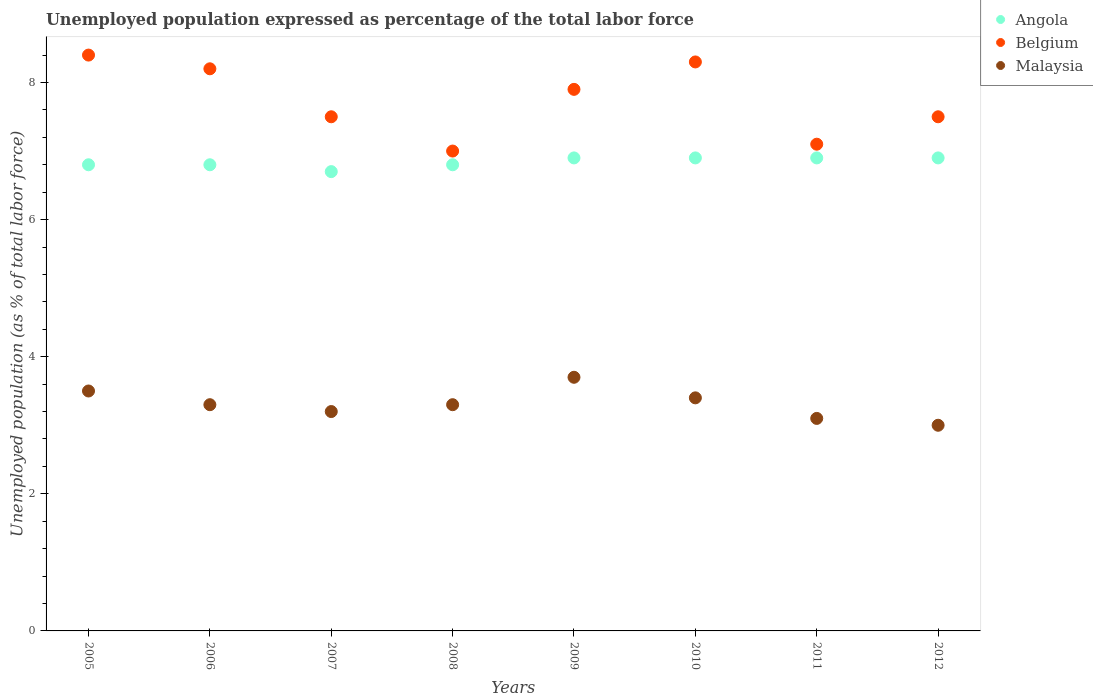How many different coloured dotlines are there?
Your answer should be very brief. 3. Is the number of dotlines equal to the number of legend labels?
Make the answer very short. Yes. What is the unemployment in in Belgium in 2007?
Ensure brevity in your answer.  7.5. Across all years, what is the maximum unemployment in in Belgium?
Your answer should be very brief. 8.4. Across all years, what is the minimum unemployment in in Angola?
Offer a very short reply. 6.7. In which year was the unemployment in in Malaysia minimum?
Your response must be concise. 2012. What is the total unemployment in in Belgium in the graph?
Your response must be concise. 61.9. What is the difference between the unemployment in in Malaysia in 2008 and that in 2010?
Your answer should be compact. -0.1. What is the difference between the unemployment in in Belgium in 2011 and the unemployment in in Malaysia in 2010?
Your answer should be compact. 3.7. What is the average unemployment in in Angola per year?
Your answer should be compact. 6.84. In the year 2009, what is the difference between the unemployment in in Angola and unemployment in in Malaysia?
Give a very brief answer. 3.2. In how many years, is the unemployment in in Angola greater than 8 %?
Make the answer very short. 0. What is the ratio of the unemployment in in Angola in 2007 to that in 2008?
Your response must be concise. 0.99. What is the difference between the highest and the second highest unemployment in in Malaysia?
Offer a very short reply. 0.2. What is the difference between the highest and the lowest unemployment in in Angola?
Provide a short and direct response. 0.2. In how many years, is the unemployment in in Angola greater than the average unemployment in in Angola taken over all years?
Provide a succinct answer. 4. Is it the case that in every year, the sum of the unemployment in in Belgium and unemployment in in Malaysia  is greater than the unemployment in in Angola?
Make the answer very short. Yes. How many dotlines are there?
Offer a terse response. 3. How many years are there in the graph?
Provide a short and direct response. 8. Where does the legend appear in the graph?
Your response must be concise. Top right. How many legend labels are there?
Your response must be concise. 3. How are the legend labels stacked?
Your answer should be compact. Vertical. What is the title of the graph?
Keep it short and to the point. Unemployed population expressed as percentage of the total labor force. What is the label or title of the X-axis?
Offer a very short reply. Years. What is the label or title of the Y-axis?
Keep it short and to the point. Unemployed population (as % of total labor force). What is the Unemployed population (as % of total labor force) of Angola in 2005?
Your answer should be compact. 6.8. What is the Unemployed population (as % of total labor force) of Belgium in 2005?
Keep it short and to the point. 8.4. What is the Unemployed population (as % of total labor force) in Malaysia in 2005?
Make the answer very short. 3.5. What is the Unemployed population (as % of total labor force) in Angola in 2006?
Provide a short and direct response. 6.8. What is the Unemployed population (as % of total labor force) of Belgium in 2006?
Offer a terse response. 8.2. What is the Unemployed population (as % of total labor force) in Malaysia in 2006?
Your response must be concise. 3.3. What is the Unemployed population (as % of total labor force) in Angola in 2007?
Ensure brevity in your answer.  6.7. What is the Unemployed population (as % of total labor force) in Belgium in 2007?
Offer a very short reply. 7.5. What is the Unemployed population (as % of total labor force) in Malaysia in 2007?
Ensure brevity in your answer.  3.2. What is the Unemployed population (as % of total labor force) of Angola in 2008?
Offer a terse response. 6.8. What is the Unemployed population (as % of total labor force) of Belgium in 2008?
Make the answer very short. 7. What is the Unemployed population (as % of total labor force) of Malaysia in 2008?
Offer a very short reply. 3.3. What is the Unemployed population (as % of total labor force) in Angola in 2009?
Your answer should be compact. 6.9. What is the Unemployed population (as % of total labor force) of Belgium in 2009?
Offer a very short reply. 7.9. What is the Unemployed population (as % of total labor force) of Malaysia in 2009?
Give a very brief answer. 3.7. What is the Unemployed population (as % of total labor force) of Angola in 2010?
Make the answer very short. 6.9. What is the Unemployed population (as % of total labor force) of Belgium in 2010?
Your answer should be very brief. 8.3. What is the Unemployed population (as % of total labor force) in Malaysia in 2010?
Provide a succinct answer. 3.4. What is the Unemployed population (as % of total labor force) of Angola in 2011?
Keep it short and to the point. 6.9. What is the Unemployed population (as % of total labor force) of Belgium in 2011?
Ensure brevity in your answer.  7.1. What is the Unemployed population (as % of total labor force) of Malaysia in 2011?
Your answer should be very brief. 3.1. What is the Unemployed population (as % of total labor force) of Angola in 2012?
Offer a terse response. 6.9. What is the Unemployed population (as % of total labor force) of Belgium in 2012?
Your answer should be compact. 7.5. Across all years, what is the maximum Unemployed population (as % of total labor force) of Angola?
Your response must be concise. 6.9. Across all years, what is the maximum Unemployed population (as % of total labor force) of Belgium?
Offer a very short reply. 8.4. Across all years, what is the maximum Unemployed population (as % of total labor force) of Malaysia?
Ensure brevity in your answer.  3.7. Across all years, what is the minimum Unemployed population (as % of total labor force) in Angola?
Provide a succinct answer. 6.7. Across all years, what is the minimum Unemployed population (as % of total labor force) in Malaysia?
Ensure brevity in your answer.  3. What is the total Unemployed population (as % of total labor force) of Angola in the graph?
Your answer should be compact. 54.7. What is the total Unemployed population (as % of total labor force) of Belgium in the graph?
Offer a very short reply. 61.9. What is the total Unemployed population (as % of total labor force) of Malaysia in the graph?
Offer a terse response. 26.5. What is the difference between the Unemployed population (as % of total labor force) in Angola in 2005 and that in 2006?
Make the answer very short. 0. What is the difference between the Unemployed population (as % of total labor force) of Malaysia in 2005 and that in 2007?
Offer a terse response. 0.3. What is the difference between the Unemployed population (as % of total labor force) of Belgium in 2005 and that in 2008?
Keep it short and to the point. 1.4. What is the difference between the Unemployed population (as % of total labor force) in Angola in 2005 and that in 2009?
Offer a terse response. -0.1. What is the difference between the Unemployed population (as % of total labor force) of Malaysia in 2005 and that in 2009?
Offer a very short reply. -0.2. What is the difference between the Unemployed population (as % of total labor force) in Belgium in 2005 and that in 2010?
Your answer should be very brief. 0.1. What is the difference between the Unemployed population (as % of total labor force) of Malaysia in 2005 and that in 2011?
Provide a succinct answer. 0.4. What is the difference between the Unemployed population (as % of total labor force) in Malaysia in 2005 and that in 2012?
Your answer should be very brief. 0.5. What is the difference between the Unemployed population (as % of total labor force) in Angola in 2006 and that in 2007?
Provide a short and direct response. 0.1. What is the difference between the Unemployed population (as % of total labor force) in Belgium in 2006 and that in 2007?
Keep it short and to the point. 0.7. What is the difference between the Unemployed population (as % of total labor force) of Malaysia in 2006 and that in 2007?
Give a very brief answer. 0.1. What is the difference between the Unemployed population (as % of total labor force) of Angola in 2006 and that in 2008?
Your answer should be compact. 0. What is the difference between the Unemployed population (as % of total labor force) of Malaysia in 2006 and that in 2008?
Give a very brief answer. 0. What is the difference between the Unemployed population (as % of total labor force) of Belgium in 2006 and that in 2010?
Offer a terse response. -0.1. What is the difference between the Unemployed population (as % of total labor force) in Belgium in 2006 and that in 2012?
Keep it short and to the point. 0.7. What is the difference between the Unemployed population (as % of total labor force) in Malaysia in 2006 and that in 2012?
Keep it short and to the point. 0.3. What is the difference between the Unemployed population (as % of total labor force) of Angola in 2007 and that in 2008?
Keep it short and to the point. -0.1. What is the difference between the Unemployed population (as % of total labor force) in Belgium in 2007 and that in 2008?
Provide a succinct answer. 0.5. What is the difference between the Unemployed population (as % of total labor force) in Malaysia in 2007 and that in 2008?
Your answer should be compact. -0.1. What is the difference between the Unemployed population (as % of total labor force) of Angola in 2007 and that in 2009?
Keep it short and to the point. -0.2. What is the difference between the Unemployed population (as % of total labor force) of Belgium in 2007 and that in 2009?
Provide a succinct answer. -0.4. What is the difference between the Unemployed population (as % of total labor force) of Malaysia in 2007 and that in 2009?
Your answer should be compact. -0.5. What is the difference between the Unemployed population (as % of total labor force) in Belgium in 2007 and that in 2010?
Ensure brevity in your answer.  -0.8. What is the difference between the Unemployed population (as % of total labor force) of Malaysia in 2007 and that in 2010?
Make the answer very short. -0.2. What is the difference between the Unemployed population (as % of total labor force) in Angola in 2007 and that in 2011?
Provide a short and direct response. -0.2. What is the difference between the Unemployed population (as % of total labor force) in Malaysia in 2007 and that in 2011?
Your answer should be very brief. 0.1. What is the difference between the Unemployed population (as % of total labor force) in Angola in 2008 and that in 2009?
Your answer should be compact. -0.1. What is the difference between the Unemployed population (as % of total labor force) in Belgium in 2008 and that in 2009?
Give a very brief answer. -0.9. What is the difference between the Unemployed population (as % of total labor force) in Malaysia in 2008 and that in 2009?
Your answer should be very brief. -0.4. What is the difference between the Unemployed population (as % of total labor force) of Belgium in 2008 and that in 2010?
Offer a very short reply. -1.3. What is the difference between the Unemployed population (as % of total labor force) of Malaysia in 2008 and that in 2010?
Your answer should be very brief. -0.1. What is the difference between the Unemployed population (as % of total labor force) of Angola in 2008 and that in 2011?
Provide a short and direct response. -0.1. What is the difference between the Unemployed population (as % of total labor force) of Belgium in 2008 and that in 2012?
Keep it short and to the point. -0.5. What is the difference between the Unemployed population (as % of total labor force) of Malaysia in 2008 and that in 2012?
Provide a succinct answer. 0.3. What is the difference between the Unemployed population (as % of total labor force) of Malaysia in 2009 and that in 2010?
Ensure brevity in your answer.  0.3. What is the difference between the Unemployed population (as % of total labor force) of Belgium in 2009 and that in 2011?
Your answer should be compact. 0.8. What is the difference between the Unemployed population (as % of total labor force) in Belgium in 2010 and that in 2011?
Make the answer very short. 1.2. What is the difference between the Unemployed population (as % of total labor force) of Malaysia in 2010 and that in 2011?
Provide a short and direct response. 0.3. What is the difference between the Unemployed population (as % of total labor force) in Belgium in 2010 and that in 2012?
Keep it short and to the point. 0.8. What is the difference between the Unemployed population (as % of total labor force) in Angola in 2011 and that in 2012?
Make the answer very short. 0. What is the difference between the Unemployed population (as % of total labor force) of Belgium in 2011 and that in 2012?
Provide a short and direct response. -0.4. What is the difference between the Unemployed population (as % of total labor force) in Angola in 2005 and the Unemployed population (as % of total labor force) in Belgium in 2006?
Your answer should be very brief. -1.4. What is the difference between the Unemployed population (as % of total labor force) of Angola in 2005 and the Unemployed population (as % of total labor force) of Malaysia in 2006?
Offer a very short reply. 3.5. What is the difference between the Unemployed population (as % of total labor force) in Angola in 2005 and the Unemployed population (as % of total labor force) in Belgium in 2008?
Your response must be concise. -0.2. What is the difference between the Unemployed population (as % of total labor force) of Angola in 2005 and the Unemployed population (as % of total labor force) of Malaysia in 2008?
Provide a succinct answer. 3.5. What is the difference between the Unemployed population (as % of total labor force) in Belgium in 2005 and the Unemployed population (as % of total labor force) in Malaysia in 2008?
Provide a short and direct response. 5.1. What is the difference between the Unemployed population (as % of total labor force) in Angola in 2005 and the Unemployed population (as % of total labor force) in Malaysia in 2009?
Offer a very short reply. 3.1. What is the difference between the Unemployed population (as % of total labor force) of Belgium in 2005 and the Unemployed population (as % of total labor force) of Malaysia in 2009?
Give a very brief answer. 4.7. What is the difference between the Unemployed population (as % of total labor force) of Angola in 2005 and the Unemployed population (as % of total labor force) of Malaysia in 2010?
Keep it short and to the point. 3.4. What is the difference between the Unemployed population (as % of total labor force) of Angola in 2005 and the Unemployed population (as % of total labor force) of Belgium in 2011?
Provide a short and direct response. -0.3. What is the difference between the Unemployed population (as % of total labor force) in Angola in 2005 and the Unemployed population (as % of total labor force) in Malaysia in 2011?
Provide a succinct answer. 3.7. What is the difference between the Unemployed population (as % of total labor force) in Angola in 2005 and the Unemployed population (as % of total labor force) in Belgium in 2012?
Make the answer very short. -0.7. What is the difference between the Unemployed population (as % of total labor force) of Angola in 2005 and the Unemployed population (as % of total labor force) of Malaysia in 2012?
Offer a terse response. 3.8. What is the difference between the Unemployed population (as % of total labor force) in Angola in 2006 and the Unemployed population (as % of total labor force) in Belgium in 2008?
Ensure brevity in your answer.  -0.2. What is the difference between the Unemployed population (as % of total labor force) in Belgium in 2006 and the Unemployed population (as % of total labor force) in Malaysia in 2008?
Give a very brief answer. 4.9. What is the difference between the Unemployed population (as % of total labor force) in Angola in 2006 and the Unemployed population (as % of total labor force) in Belgium in 2009?
Offer a very short reply. -1.1. What is the difference between the Unemployed population (as % of total labor force) of Angola in 2006 and the Unemployed population (as % of total labor force) of Malaysia in 2009?
Provide a succinct answer. 3.1. What is the difference between the Unemployed population (as % of total labor force) of Belgium in 2006 and the Unemployed population (as % of total labor force) of Malaysia in 2009?
Provide a succinct answer. 4.5. What is the difference between the Unemployed population (as % of total labor force) in Angola in 2006 and the Unemployed population (as % of total labor force) in Belgium in 2010?
Provide a short and direct response. -1.5. What is the difference between the Unemployed population (as % of total labor force) in Angola in 2006 and the Unemployed population (as % of total labor force) in Malaysia in 2010?
Offer a terse response. 3.4. What is the difference between the Unemployed population (as % of total labor force) of Belgium in 2006 and the Unemployed population (as % of total labor force) of Malaysia in 2011?
Your response must be concise. 5.1. What is the difference between the Unemployed population (as % of total labor force) of Belgium in 2006 and the Unemployed population (as % of total labor force) of Malaysia in 2012?
Your answer should be compact. 5.2. What is the difference between the Unemployed population (as % of total labor force) of Angola in 2007 and the Unemployed population (as % of total labor force) of Belgium in 2009?
Offer a very short reply. -1.2. What is the difference between the Unemployed population (as % of total labor force) of Angola in 2007 and the Unemployed population (as % of total labor force) of Malaysia in 2009?
Provide a short and direct response. 3. What is the difference between the Unemployed population (as % of total labor force) of Belgium in 2007 and the Unemployed population (as % of total labor force) of Malaysia in 2009?
Make the answer very short. 3.8. What is the difference between the Unemployed population (as % of total labor force) of Angola in 2007 and the Unemployed population (as % of total labor force) of Malaysia in 2010?
Your answer should be compact. 3.3. What is the difference between the Unemployed population (as % of total labor force) of Angola in 2007 and the Unemployed population (as % of total labor force) of Belgium in 2011?
Provide a short and direct response. -0.4. What is the difference between the Unemployed population (as % of total labor force) of Angola in 2007 and the Unemployed population (as % of total labor force) of Malaysia in 2011?
Provide a short and direct response. 3.6. What is the difference between the Unemployed population (as % of total labor force) of Angola in 2008 and the Unemployed population (as % of total labor force) of Malaysia in 2010?
Offer a very short reply. 3.4. What is the difference between the Unemployed population (as % of total labor force) in Belgium in 2008 and the Unemployed population (as % of total labor force) in Malaysia in 2010?
Keep it short and to the point. 3.6. What is the difference between the Unemployed population (as % of total labor force) of Angola in 2008 and the Unemployed population (as % of total labor force) of Belgium in 2012?
Your answer should be compact. -0.7. What is the difference between the Unemployed population (as % of total labor force) of Angola in 2008 and the Unemployed population (as % of total labor force) of Malaysia in 2012?
Ensure brevity in your answer.  3.8. What is the difference between the Unemployed population (as % of total labor force) of Angola in 2009 and the Unemployed population (as % of total labor force) of Belgium in 2010?
Your answer should be very brief. -1.4. What is the difference between the Unemployed population (as % of total labor force) of Angola in 2009 and the Unemployed population (as % of total labor force) of Malaysia in 2010?
Provide a short and direct response. 3.5. What is the difference between the Unemployed population (as % of total labor force) in Angola in 2009 and the Unemployed population (as % of total labor force) in Belgium in 2011?
Keep it short and to the point. -0.2. What is the difference between the Unemployed population (as % of total labor force) in Angola in 2009 and the Unemployed population (as % of total labor force) in Malaysia in 2011?
Offer a terse response. 3.8. What is the difference between the Unemployed population (as % of total labor force) in Belgium in 2009 and the Unemployed population (as % of total labor force) in Malaysia in 2011?
Give a very brief answer. 4.8. What is the difference between the Unemployed population (as % of total labor force) of Angola in 2009 and the Unemployed population (as % of total labor force) of Malaysia in 2012?
Your response must be concise. 3.9. What is the difference between the Unemployed population (as % of total labor force) of Belgium in 2010 and the Unemployed population (as % of total labor force) of Malaysia in 2011?
Provide a short and direct response. 5.2. What is the difference between the Unemployed population (as % of total labor force) of Angola in 2010 and the Unemployed population (as % of total labor force) of Belgium in 2012?
Offer a very short reply. -0.6. What is the difference between the Unemployed population (as % of total labor force) of Belgium in 2010 and the Unemployed population (as % of total labor force) of Malaysia in 2012?
Keep it short and to the point. 5.3. What is the difference between the Unemployed population (as % of total labor force) of Angola in 2011 and the Unemployed population (as % of total labor force) of Belgium in 2012?
Your answer should be compact. -0.6. What is the difference between the Unemployed population (as % of total labor force) of Angola in 2011 and the Unemployed population (as % of total labor force) of Malaysia in 2012?
Offer a terse response. 3.9. What is the difference between the Unemployed population (as % of total labor force) in Belgium in 2011 and the Unemployed population (as % of total labor force) in Malaysia in 2012?
Keep it short and to the point. 4.1. What is the average Unemployed population (as % of total labor force) in Angola per year?
Give a very brief answer. 6.84. What is the average Unemployed population (as % of total labor force) of Belgium per year?
Offer a terse response. 7.74. What is the average Unemployed population (as % of total labor force) of Malaysia per year?
Offer a terse response. 3.31. In the year 2005, what is the difference between the Unemployed population (as % of total labor force) of Angola and Unemployed population (as % of total labor force) of Belgium?
Your answer should be compact. -1.6. In the year 2005, what is the difference between the Unemployed population (as % of total labor force) of Angola and Unemployed population (as % of total labor force) of Malaysia?
Your answer should be very brief. 3.3. In the year 2005, what is the difference between the Unemployed population (as % of total labor force) of Belgium and Unemployed population (as % of total labor force) of Malaysia?
Your answer should be very brief. 4.9. In the year 2006, what is the difference between the Unemployed population (as % of total labor force) of Angola and Unemployed population (as % of total labor force) of Belgium?
Give a very brief answer. -1.4. In the year 2006, what is the difference between the Unemployed population (as % of total labor force) of Angola and Unemployed population (as % of total labor force) of Malaysia?
Make the answer very short. 3.5. In the year 2008, what is the difference between the Unemployed population (as % of total labor force) in Angola and Unemployed population (as % of total labor force) in Malaysia?
Your answer should be compact. 3.5. In the year 2009, what is the difference between the Unemployed population (as % of total labor force) in Angola and Unemployed population (as % of total labor force) in Belgium?
Your response must be concise. -1. In the year 2009, what is the difference between the Unemployed population (as % of total labor force) in Belgium and Unemployed population (as % of total labor force) in Malaysia?
Offer a terse response. 4.2. In the year 2010, what is the difference between the Unemployed population (as % of total labor force) in Angola and Unemployed population (as % of total labor force) in Belgium?
Provide a short and direct response. -1.4. In the year 2011, what is the difference between the Unemployed population (as % of total labor force) in Angola and Unemployed population (as % of total labor force) in Malaysia?
Ensure brevity in your answer.  3.8. What is the ratio of the Unemployed population (as % of total labor force) in Belgium in 2005 to that in 2006?
Your answer should be very brief. 1.02. What is the ratio of the Unemployed population (as % of total labor force) of Malaysia in 2005 to that in 2006?
Keep it short and to the point. 1.06. What is the ratio of the Unemployed population (as % of total labor force) in Angola in 2005 to that in 2007?
Provide a short and direct response. 1.01. What is the ratio of the Unemployed population (as % of total labor force) of Belgium in 2005 to that in 2007?
Provide a short and direct response. 1.12. What is the ratio of the Unemployed population (as % of total labor force) in Malaysia in 2005 to that in 2007?
Keep it short and to the point. 1.09. What is the ratio of the Unemployed population (as % of total labor force) in Malaysia in 2005 to that in 2008?
Provide a short and direct response. 1.06. What is the ratio of the Unemployed population (as % of total labor force) of Angola in 2005 to that in 2009?
Provide a succinct answer. 0.99. What is the ratio of the Unemployed population (as % of total labor force) in Belgium in 2005 to that in 2009?
Keep it short and to the point. 1.06. What is the ratio of the Unemployed population (as % of total labor force) of Malaysia in 2005 to that in 2009?
Offer a very short reply. 0.95. What is the ratio of the Unemployed population (as % of total labor force) in Angola in 2005 to that in 2010?
Ensure brevity in your answer.  0.99. What is the ratio of the Unemployed population (as % of total labor force) in Belgium in 2005 to that in 2010?
Make the answer very short. 1.01. What is the ratio of the Unemployed population (as % of total labor force) in Malaysia in 2005 to that in 2010?
Offer a very short reply. 1.03. What is the ratio of the Unemployed population (as % of total labor force) in Angola in 2005 to that in 2011?
Provide a succinct answer. 0.99. What is the ratio of the Unemployed population (as % of total labor force) of Belgium in 2005 to that in 2011?
Your answer should be very brief. 1.18. What is the ratio of the Unemployed population (as % of total labor force) of Malaysia in 2005 to that in 2011?
Your answer should be very brief. 1.13. What is the ratio of the Unemployed population (as % of total labor force) in Angola in 2005 to that in 2012?
Offer a very short reply. 0.99. What is the ratio of the Unemployed population (as % of total labor force) in Belgium in 2005 to that in 2012?
Offer a very short reply. 1.12. What is the ratio of the Unemployed population (as % of total labor force) in Malaysia in 2005 to that in 2012?
Your answer should be compact. 1.17. What is the ratio of the Unemployed population (as % of total labor force) in Angola in 2006 to that in 2007?
Give a very brief answer. 1.01. What is the ratio of the Unemployed population (as % of total labor force) of Belgium in 2006 to that in 2007?
Offer a terse response. 1.09. What is the ratio of the Unemployed population (as % of total labor force) of Malaysia in 2006 to that in 2007?
Make the answer very short. 1.03. What is the ratio of the Unemployed population (as % of total labor force) in Belgium in 2006 to that in 2008?
Your answer should be very brief. 1.17. What is the ratio of the Unemployed population (as % of total labor force) in Malaysia in 2006 to that in 2008?
Provide a short and direct response. 1. What is the ratio of the Unemployed population (as % of total labor force) of Angola in 2006 to that in 2009?
Your response must be concise. 0.99. What is the ratio of the Unemployed population (as % of total labor force) in Belgium in 2006 to that in 2009?
Offer a very short reply. 1.04. What is the ratio of the Unemployed population (as % of total labor force) in Malaysia in 2006 to that in 2009?
Provide a succinct answer. 0.89. What is the ratio of the Unemployed population (as % of total labor force) in Angola in 2006 to that in 2010?
Your answer should be compact. 0.99. What is the ratio of the Unemployed population (as % of total labor force) in Malaysia in 2006 to that in 2010?
Offer a very short reply. 0.97. What is the ratio of the Unemployed population (as % of total labor force) of Angola in 2006 to that in 2011?
Your response must be concise. 0.99. What is the ratio of the Unemployed population (as % of total labor force) in Belgium in 2006 to that in 2011?
Your response must be concise. 1.15. What is the ratio of the Unemployed population (as % of total labor force) of Malaysia in 2006 to that in 2011?
Make the answer very short. 1.06. What is the ratio of the Unemployed population (as % of total labor force) of Angola in 2006 to that in 2012?
Ensure brevity in your answer.  0.99. What is the ratio of the Unemployed population (as % of total labor force) in Belgium in 2006 to that in 2012?
Offer a terse response. 1.09. What is the ratio of the Unemployed population (as % of total labor force) in Belgium in 2007 to that in 2008?
Your answer should be compact. 1.07. What is the ratio of the Unemployed population (as % of total labor force) of Malaysia in 2007 to that in 2008?
Give a very brief answer. 0.97. What is the ratio of the Unemployed population (as % of total labor force) in Angola in 2007 to that in 2009?
Provide a short and direct response. 0.97. What is the ratio of the Unemployed population (as % of total labor force) in Belgium in 2007 to that in 2009?
Your answer should be very brief. 0.95. What is the ratio of the Unemployed population (as % of total labor force) of Malaysia in 2007 to that in 2009?
Provide a short and direct response. 0.86. What is the ratio of the Unemployed population (as % of total labor force) of Angola in 2007 to that in 2010?
Give a very brief answer. 0.97. What is the ratio of the Unemployed population (as % of total labor force) in Belgium in 2007 to that in 2010?
Your answer should be compact. 0.9. What is the ratio of the Unemployed population (as % of total labor force) of Angola in 2007 to that in 2011?
Ensure brevity in your answer.  0.97. What is the ratio of the Unemployed population (as % of total labor force) of Belgium in 2007 to that in 2011?
Provide a short and direct response. 1.06. What is the ratio of the Unemployed population (as % of total labor force) in Malaysia in 2007 to that in 2011?
Offer a very short reply. 1.03. What is the ratio of the Unemployed population (as % of total labor force) in Angola in 2007 to that in 2012?
Offer a terse response. 0.97. What is the ratio of the Unemployed population (as % of total labor force) of Belgium in 2007 to that in 2012?
Provide a succinct answer. 1. What is the ratio of the Unemployed population (as % of total labor force) in Malaysia in 2007 to that in 2012?
Your answer should be compact. 1.07. What is the ratio of the Unemployed population (as % of total labor force) in Angola in 2008 to that in 2009?
Provide a succinct answer. 0.99. What is the ratio of the Unemployed population (as % of total labor force) of Belgium in 2008 to that in 2009?
Your response must be concise. 0.89. What is the ratio of the Unemployed population (as % of total labor force) of Malaysia in 2008 to that in 2009?
Offer a very short reply. 0.89. What is the ratio of the Unemployed population (as % of total labor force) of Angola in 2008 to that in 2010?
Give a very brief answer. 0.99. What is the ratio of the Unemployed population (as % of total labor force) in Belgium in 2008 to that in 2010?
Offer a very short reply. 0.84. What is the ratio of the Unemployed population (as % of total labor force) of Malaysia in 2008 to that in 2010?
Provide a succinct answer. 0.97. What is the ratio of the Unemployed population (as % of total labor force) in Angola in 2008 to that in 2011?
Ensure brevity in your answer.  0.99. What is the ratio of the Unemployed population (as % of total labor force) of Belgium in 2008 to that in 2011?
Give a very brief answer. 0.99. What is the ratio of the Unemployed population (as % of total labor force) in Malaysia in 2008 to that in 2011?
Offer a terse response. 1.06. What is the ratio of the Unemployed population (as % of total labor force) in Angola in 2008 to that in 2012?
Offer a terse response. 0.99. What is the ratio of the Unemployed population (as % of total labor force) of Malaysia in 2008 to that in 2012?
Make the answer very short. 1.1. What is the ratio of the Unemployed population (as % of total labor force) in Angola in 2009 to that in 2010?
Your answer should be compact. 1. What is the ratio of the Unemployed population (as % of total labor force) in Belgium in 2009 to that in 2010?
Your response must be concise. 0.95. What is the ratio of the Unemployed population (as % of total labor force) in Malaysia in 2009 to that in 2010?
Your response must be concise. 1.09. What is the ratio of the Unemployed population (as % of total labor force) in Belgium in 2009 to that in 2011?
Your answer should be very brief. 1.11. What is the ratio of the Unemployed population (as % of total labor force) of Malaysia in 2009 to that in 2011?
Your answer should be compact. 1.19. What is the ratio of the Unemployed population (as % of total labor force) of Belgium in 2009 to that in 2012?
Provide a short and direct response. 1.05. What is the ratio of the Unemployed population (as % of total labor force) in Malaysia in 2009 to that in 2012?
Give a very brief answer. 1.23. What is the ratio of the Unemployed population (as % of total labor force) in Belgium in 2010 to that in 2011?
Your response must be concise. 1.17. What is the ratio of the Unemployed population (as % of total labor force) in Malaysia in 2010 to that in 2011?
Your answer should be very brief. 1.1. What is the ratio of the Unemployed population (as % of total labor force) in Angola in 2010 to that in 2012?
Offer a very short reply. 1. What is the ratio of the Unemployed population (as % of total labor force) in Belgium in 2010 to that in 2012?
Your answer should be very brief. 1.11. What is the ratio of the Unemployed population (as % of total labor force) of Malaysia in 2010 to that in 2012?
Keep it short and to the point. 1.13. What is the ratio of the Unemployed population (as % of total labor force) in Angola in 2011 to that in 2012?
Offer a terse response. 1. What is the ratio of the Unemployed population (as % of total labor force) in Belgium in 2011 to that in 2012?
Your response must be concise. 0.95. What is the ratio of the Unemployed population (as % of total labor force) of Malaysia in 2011 to that in 2012?
Provide a succinct answer. 1.03. What is the difference between the highest and the second highest Unemployed population (as % of total labor force) of Angola?
Ensure brevity in your answer.  0. What is the difference between the highest and the second highest Unemployed population (as % of total labor force) in Belgium?
Your answer should be compact. 0.1. What is the difference between the highest and the lowest Unemployed population (as % of total labor force) in Malaysia?
Offer a terse response. 0.7. 